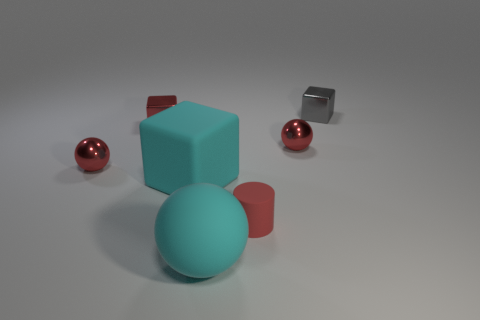Add 2 rubber cubes. How many objects exist? 9 Subtract 3 balls. How many balls are left? 0 Subtract all red balls. How many balls are left? 1 Subtract all cylinders. How many objects are left? 6 Add 6 cyan spheres. How many cyan spheres exist? 7 Subtract all cyan spheres. How many spheres are left? 2 Subtract 0 gray spheres. How many objects are left? 7 Subtract all brown blocks. Subtract all green cylinders. How many blocks are left? 3 Subtract all brown balls. How many cyan cubes are left? 1 Subtract all gray rubber balls. Subtract all tiny red metallic spheres. How many objects are left? 5 